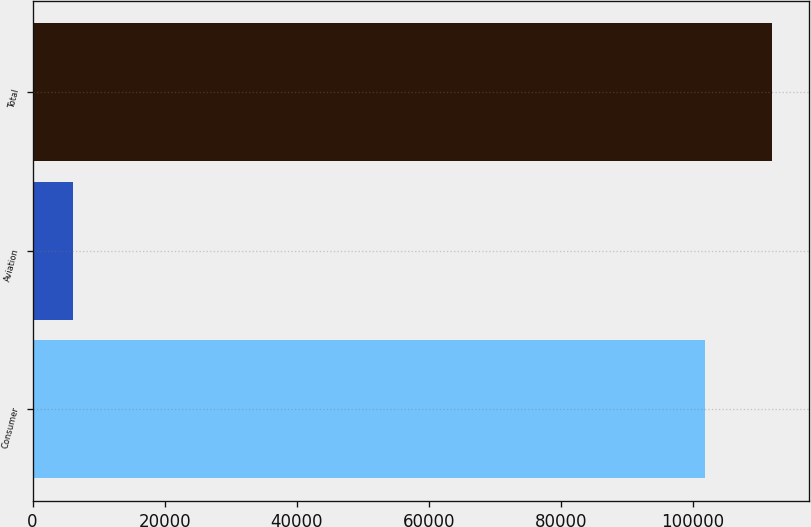Convert chart. <chart><loc_0><loc_0><loc_500><loc_500><bar_chart><fcel>Consumer<fcel>Aviation<fcel>Total<nl><fcel>101763<fcel>6082<fcel>111939<nl></chart> 